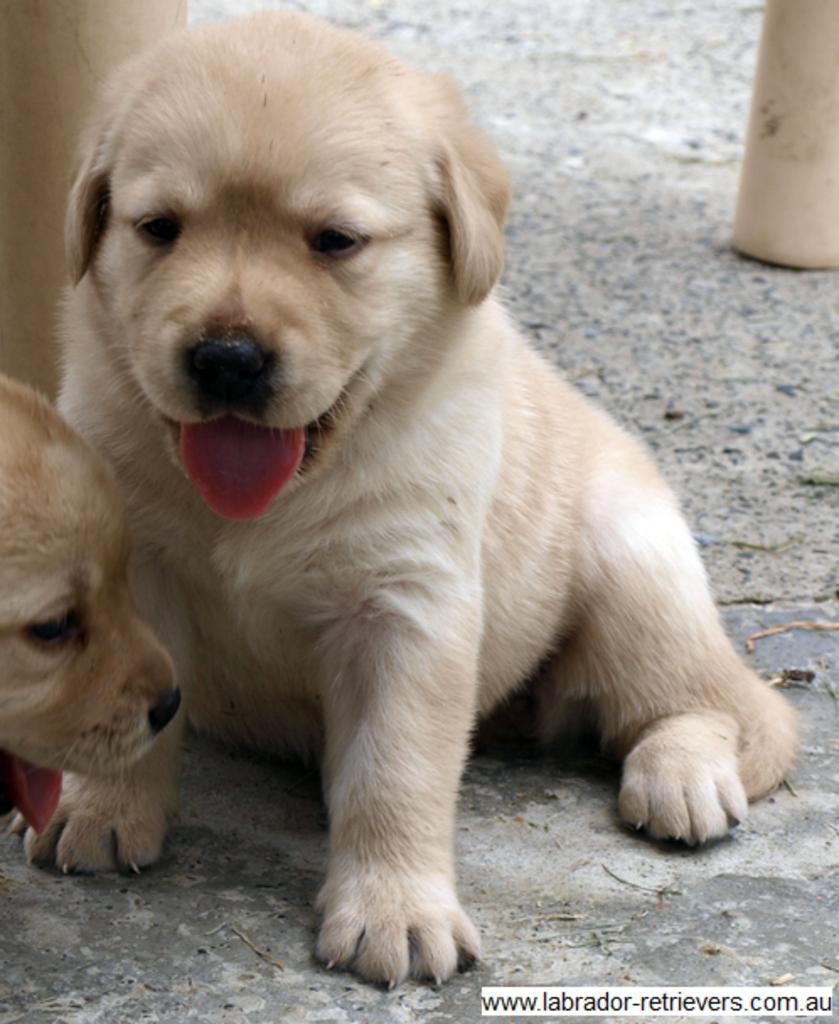What type of animals are present in the image? There are dogs in the image. What can be seen in the background of the image? There are objects in the background of the image. Where is the text located in the image? The text is in the bottom right side of the image. What type of comb is being used by the dogs in the image? There is no comb present in the image, and the dogs are not using any comb. 